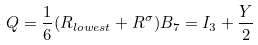<formula> <loc_0><loc_0><loc_500><loc_500>Q = \frac { 1 } { 6 } ( R _ { l o w e s t } + R ^ { \sigma } ) B _ { 7 } = I _ { 3 } + \frac { Y } { 2 }</formula> 